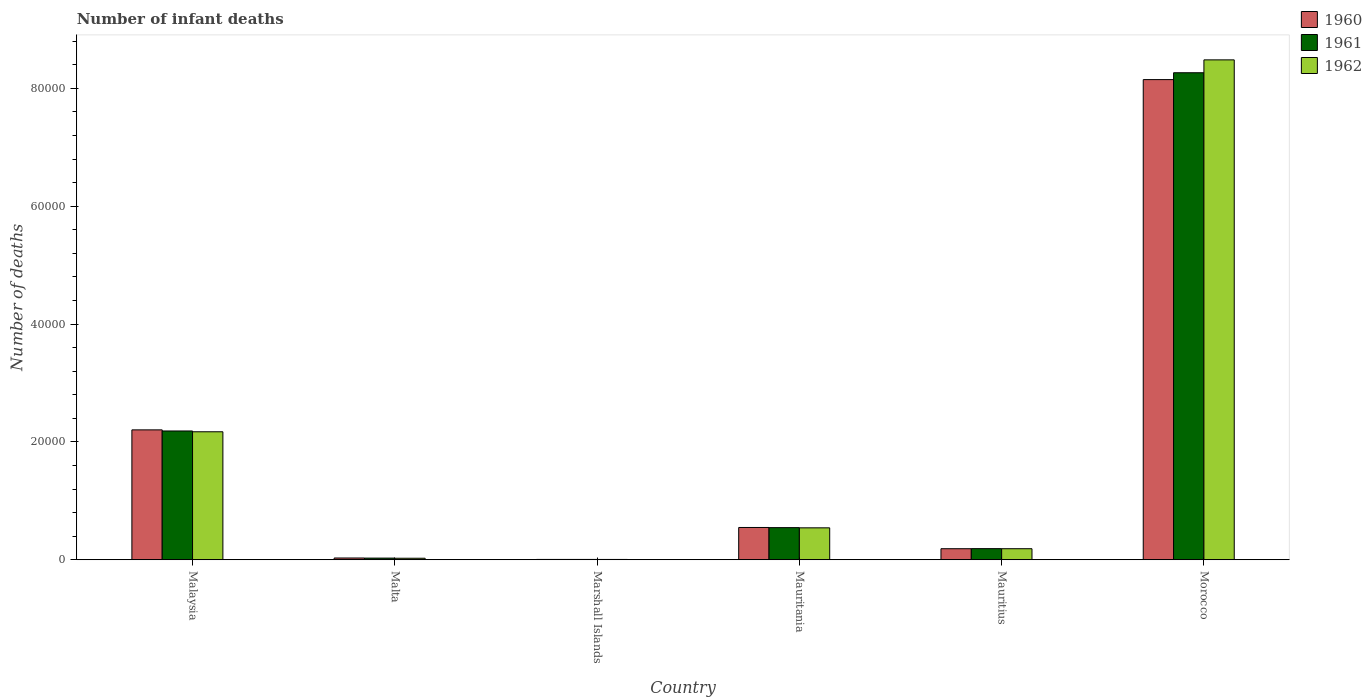How many groups of bars are there?
Your answer should be compact. 6. Are the number of bars per tick equal to the number of legend labels?
Your answer should be very brief. Yes. Are the number of bars on each tick of the X-axis equal?
Offer a terse response. Yes. How many bars are there on the 2nd tick from the left?
Provide a short and direct response. 3. What is the label of the 2nd group of bars from the left?
Your answer should be very brief. Malta. What is the number of infant deaths in 1962 in Mauritius?
Your response must be concise. 1876. Across all countries, what is the maximum number of infant deaths in 1962?
Your answer should be compact. 8.48e+04. In which country was the number of infant deaths in 1960 maximum?
Your answer should be compact. Morocco. In which country was the number of infant deaths in 1961 minimum?
Ensure brevity in your answer.  Marshall Islands. What is the total number of infant deaths in 1962 in the graph?
Your answer should be compact. 1.14e+05. What is the difference between the number of infant deaths in 1961 in Malta and that in Mauritania?
Make the answer very short. -5171. What is the difference between the number of infant deaths in 1961 in Mauritius and the number of infant deaths in 1962 in Malaysia?
Ensure brevity in your answer.  -1.98e+04. What is the average number of infant deaths in 1960 per country?
Provide a succinct answer. 1.85e+04. What is the difference between the number of infant deaths of/in 1962 and number of infant deaths of/in 1960 in Morocco?
Your response must be concise. 3350. In how many countries, is the number of infant deaths in 1962 greater than 52000?
Keep it short and to the point. 1. What is the ratio of the number of infant deaths in 1962 in Marshall Islands to that in Mauritania?
Your response must be concise. 0.01. What is the difference between the highest and the second highest number of infant deaths in 1962?
Make the answer very short. 1.63e+04. What is the difference between the highest and the lowest number of infant deaths in 1962?
Your answer should be compact. 8.48e+04. Is it the case that in every country, the sum of the number of infant deaths in 1962 and number of infant deaths in 1961 is greater than the number of infant deaths in 1960?
Offer a very short reply. Yes. Are all the bars in the graph horizontal?
Offer a very short reply. No. What is the difference between two consecutive major ticks on the Y-axis?
Ensure brevity in your answer.  2.00e+04. Does the graph contain grids?
Ensure brevity in your answer.  No. Where does the legend appear in the graph?
Ensure brevity in your answer.  Top right. How are the legend labels stacked?
Give a very brief answer. Vertical. What is the title of the graph?
Your answer should be compact. Number of infant deaths. What is the label or title of the X-axis?
Make the answer very short. Country. What is the label or title of the Y-axis?
Your response must be concise. Number of deaths. What is the Number of deaths of 1960 in Malaysia?
Provide a short and direct response. 2.20e+04. What is the Number of deaths of 1961 in Malaysia?
Offer a terse response. 2.19e+04. What is the Number of deaths of 1962 in Malaysia?
Make the answer very short. 2.17e+04. What is the Number of deaths in 1960 in Malta?
Your answer should be very brief. 301. What is the Number of deaths of 1961 in Malta?
Make the answer very short. 283. What is the Number of deaths in 1962 in Malta?
Provide a short and direct response. 258. What is the Number of deaths in 1960 in Mauritania?
Provide a succinct answer. 5480. What is the Number of deaths of 1961 in Mauritania?
Offer a very short reply. 5454. What is the Number of deaths of 1962 in Mauritania?
Make the answer very short. 5420. What is the Number of deaths of 1960 in Mauritius?
Offer a very short reply. 1875. What is the Number of deaths of 1961 in Mauritius?
Offer a terse response. 1890. What is the Number of deaths in 1962 in Mauritius?
Provide a short and direct response. 1876. What is the Number of deaths in 1960 in Morocco?
Provide a succinct answer. 8.15e+04. What is the Number of deaths of 1961 in Morocco?
Offer a terse response. 8.27e+04. What is the Number of deaths in 1962 in Morocco?
Offer a terse response. 8.48e+04. Across all countries, what is the maximum Number of deaths of 1960?
Offer a very short reply. 8.15e+04. Across all countries, what is the maximum Number of deaths in 1961?
Keep it short and to the point. 8.27e+04. Across all countries, what is the maximum Number of deaths in 1962?
Give a very brief answer. 8.48e+04. Across all countries, what is the minimum Number of deaths of 1961?
Make the answer very short. 56. What is the total Number of deaths in 1960 in the graph?
Keep it short and to the point. 1.11e+05. What is the total Number of deaths in 1961 in the graph?
Offer a terse response. 1.12e+05. What is the total Number of deaths in 1962 in the graph?
Your response must be concise. 1.14e+05. What is the difference between the Number of deaths of 1960 in Malaysia and that in Malta?
Offer a very short reply. 2.17e+04. What is the difference between the Number of deaths in 1961 in Malaysia and that in Malta?
Provide a succinct answer. 2.16e+04. What is the difference between the Number of deaths of 1962 in Malaysia and that in Malta?
Offer a terse response. 2.15e+04. What is the difference between the Number of deaths of 1960 in Malaysia and that in Marshall Islands?
Provide a short and direct response. 2.20e+04. What is the difference between the Number of deaths in 1961 in Malaysia and that in Marshall Islands?
Keep it short and to the point. 2.18e+04. What is the difference between the Number of deaths of 1962 in Malaysia and that in Marshall Islands?
Your response must be concise. 2.17e+04. What is the difference between the Number of deaths of 1960 in Malaysia and that in Mauritania?
Provide a short and direct response. 1.66e+04. What is the difference between the Number of deaths of 1961 in Malaysia and that in Mauritania?
Your answer should be compact. 1.64e+04. What is the difference between the Number of deaths of 1962 in Malaysia and that in Mauritania?
Give a very brief answer. 1.63e+04. What is the difference between the Number of deaths of 1960 in Malaysia and that in Mauritius?
Provide a short and direct response. 2.02e+04. What is the difference between the Number of deaths of 1961 in Malaysia and that in Mauritius?
Offer a very short reply. 2.00e+04. What is the difference between the Number of deaths of 1962 in Malaysia and that in Mauritius?
Offer a very short reply. 1.98e+04. What is the difference between the Number of deaths of 1960 in Malaysia and that in Morocco?
Offer a terse response. -5.94e+04. What is the difference between the Number of deaths in 1961 in Malaysia and that in Morocco?
Your answer should be compact. -6.08e+04. What is the difference between the Number of deaths of 1962 in Malaysia and that in Morocco?
Offer a terse response. -6.31e+04. What is the difference between the Number of deaths of 1960 in Malta and that in Marshall Islands?
Provide a succinct answer. 244. What is the difference between the Number of deaths of 1961 in Malta and that in Marshall Islands?
Provide a short and direct response. 227. What is the difference between the Number of deaths of 1962 in Malta and that in Marshall Islands?
Make the answer very short. 203. What is the difference between the Number of deaths in 1960 in Malta and that in Mauritania?
Provide a short and direct response. -5179. What is the difference between the Number of deaths in 1961 in Malta and that in Mauritania?
Offer a terse response. -5171. What is the difference between the Number of deaths in 1962 in Malta and that in Mauritania?
Your response must be concise. -5162. What is the difference between the Number of deaths in 1960 in Malta and that in Mauritius?
Keep it short and to the point. -1574. What is the difference between the Number of deaths in 1961 in Malta and that in Mauritius?
Provide a succinct answer. -1607. What is the difference between the Number of deaths of 1962 in Malta and that in Mauritius?
Offer a terse response. -1618. What is the difference between the Number of deaths of 1960 in Malta and that in Morocco?
Ensure brevity in your answer.  -8.12e+04. What is the difference between the Number of deaths of 1961 in Malta and that in Morocco?
Offer a very short reply. -8.24e+04. What is the difference between the Number of deaths in 1962 in Malta and that in Morocco?
Offer a very short reply. -8.46e+04. What is the difference between the Number of deaths of 1960 in Marshall Islands and that in Mauritania?
Your response must be concise. -5423. What is the difference between the Number of deaths of 1961 in Marshall Islands and that in Mauritania?
Ensure brevity in your answer.  -5398. What is the difference between the Number of deaths of 1962 in Marshall Islands and that in Mauritania?
Your answer should be compact. -5365. What is the difference between the Number of deaths in 1960 in Marshall Islands and that in Mauritius?
Offer a very short reply. -1818. What is the difference between the Number of deaths of 1961 in Marshall Islands and that in Mauritius?
Offer a terse response. -1834. What is the difference between the Number of deaths in 1962 in Marshall Islands and that in Mauritius?
Offer a very short reply. -1821. What is the difference between the Number of deaths of 1960 in Marshall Islands and that in Morocco?
Give a very brief answer. -8.14e+04. What is the difference between the Number of deaths in 1961 in Marshall Islands and that in Morocco?
Keep it short and to the point. -8.26e+04. What is the difference between the Number of deaths in 1962 in Marshall Islands and that in Morocco?
Provide a short and direct response. -8.48e+04. What is the difference between the Number of deaths in 1960 in Mauritania and that in Mauritius?
Your response must be concise. 3605. What is the difference between the Number of deaths in 1961 in Mauritania and that in Mauritius?
Ensure brevity in your answer.  3564. What is the difference between the Number of deaths of 1962 in Mauritania and that in Mauritius?
Give a very brief answer. 3544. What is the difference between the Number of deaths of 1960 in Mauritania and that in Morocco?
Give a very brief answer. -7.60e+04. What is the difference between the Number of deaths of 1961 in Mauritania and that in Morocco?
Your answer should be very brief. -7.72e+04. What is the difference between the Number of deaths in 1962 in Mauritania and that in Morocco?
Your response must be concise. -7.94e+04. What is the difference between the Number of deaths of 1960 in Mauritius and that in Morocco?
Provide a succinct answer. -7.96e+04. What is the difference between the Number of deaths of 1961 in Mauritius and that in Morocco?
Offer a terse response. -8.08e+04. What is the difference between the Number of deaths of 1962 in Mauritius and that in Morocco?
Provide a succinct answer. -8.30e+04. What is the difference between the Number of deaths of 1960 in Malaysia and the Number of deaths of 1961 in Malta?
Ensure brevity in your answer.  2.18e+04. What is the difference between the Number of deaths of 1960 in Malaysia and the Number of deaths of 1962 in Malta?
Your answer should be very brief. 2.18e+04. What is the difference between the Number of deaths in 1961 in Malaysia and the Number of deaths in 1962 in Malta?
Give a very brief answer. 2.16e+04. What is the difference between the Number of deaths in 1960 in Malaysia and the Number of deaths in 1961 in Marshall Islands?
Provide a succinct answer. 2.20e+04. What is the difference between the Number of deaths in 1960 in Malaysia and the Number of deaths in 1962 in Marshall Islands?
Your answer should be very brief. 2.20e+04. What is the difference between the Number of deaths of 1961 in Malaysia and the Number of deaths of 1962 in Marshall Islands?
Ensure brevity in your answer.  2.18e+04. What is the difference between the Number of deaths in 1960 in Malaysia and the Number of deaths in 1961 in Mauritania?
Make the answer very short. 1.66e+04. What is the difference between the Number of deaths in 1960 in Malaysia and the Number of deaths in 1962 in Mauritania?
Provide a succinct answer. 1.66e+04. What is the difference between the Number of deaths in 1961 in Malaysia and the Number of deaths in 1962 in Mauritania?
Make the answer very short. 1.64e+04. What is the difference between the Number of deaths of 1960 in Malaysia and the Number of deaths of 1961 in Mauritius?
Provide a short and direct response. 2.02e+04. What is the difference between the Number of deaths in 1960 in Malaysia and the Number of deaths in 1962 in Mauritius?
Keep it short and to the point. 2.02e+04. What is the difference between the Number of deaths in 1961 in Malaysia and the Number of deaths in 1962 in Mauritius?
Keep it short and to the point. 2.00e+04. What is the difference between the Number of deaths of 1960 in Malaysia and the Number of deaths of 1961 in Morocco?
Make the answer very short. -6.06e+04. What is the difference between the Number of deaths in 1960 in Malaysia and the Number of deaths in 1962 in Morocco?
Make the answer very short. -6.28e+04. What is the difference between the Number of deaths in 1961 in Malaysia and the Number of deaths in 1962 in Morocco?
Your answer should be very brief. -6.30e+04. What is the difference between the Number of deaths in 1960 in Malta and the Number of deaths in 1961 in Marshall Islands?
Your answer should be very brief. 245. What is the difference between the Number of deaths in 1960 in Malta and the Number of deaths in 1962 in Marshall Islands?
Give a very brief answer. 246. What is the difference between the Number of deaths of 1961 in Malta and the Number of deaths of 1962 in Marshall Islands?
Offer a very short reply. 228. What is the difference between the Number of deaths of 1960 in Malta and the Number of deaths of 1961 in Mauritania?
Provide a succinct answer. -5153. What is the difference between the Number of deaths in 1960 in Malta and the Number of deaths in 1962 in Mauritania?
Your answer should be compact. -5119. What is the difference between the Number of deaths of 1961 in Malta and the Number of deaths of 1962 in Mauritania?
Offer a very short reply. -5137. What is the difference between the Number of deaths of 1960 in Malta and the Number of deaths of 1961 in Mauritius?
Your answer should be compact. -1589. What is the difference between the Number of deaths in 1960 in Malta and the Number of deaths in 1962 in Mauritius?
Your answer should be very brief. -1575. What is the difference between the Number of deaths in 1961 in Malta and the Number of deaths in 1962 in Mauritius?
Make the answer very short. -1593. What is the difference between the Number of deaths of 1960 in Malta and the Number of deaths of 1961 in Morocco?
Offer a very short reply. -8.24e+04. What is the difference between the Number of deaths in 1960 in Malta and the Number of deaths in 1962 in Morocco?
Your answer should be compact. -8.45e+04. What is the difference between the Number of deaths of 1961 in Malta and the Number of deaths of 1962 in Morocco?
Provide a succinct answer. -8.46e+04. What is the difference between the Number of deaths of 1960 in Marshall Islands and the Number of deaths of 1961 in Mauritania?
Your answer should be compact. -5397. What is the difference between the Number of deaths in 1960 in Marshall Islands and the Number of deaths in 1962 in Mauritania?
Provide a short and direct response. -5363. What is the difference between the Number of deaths in 1961 in Marshall Islands and the Number of deaths in 1962 in Mauritania?
Provide a succinct answer. -5364. What is the difference between the Number of deaths in 1960 in Marshall Islands and the Number of deaths in 1961 in Mauritius?
Your answer should be compact. -1833. What is the difference between the Number of deaths in 1960 in Marshall Islands and the Number of deaths in 1962 in Mauritius?
Ensure brevity in your answer.  -1819. What is the difference between the Number of deaths of 1961 in Marshall Islands and the Number of deaths of 1962 in Mauritius?
Offer a terse response. -1820. What is the difference between the Number of deaths in 1960 in Marshall Islands and the Number of deaths in 1961 in Morocco?
Keep it short and to the point. -8.26e+04. What is the difference between the Number of deaths in 1960 in Marshall Islands and the Number of deaths in 1962 in Morocco?
Your answer should be compact. -8.48e+04. What is the difference between the Number of deaths in 1961 in Marshall Islands and the Number of deaths in 1962 in Morocco?
Provide a succinct answer. -8.48e+04. What is the difference between the Number of deaths of 1960 in Mauritania and the Number of deaths of 1961 in Mauritius?
Ensure brevity in your answer.  3590. What is the difference between the Number of deaths in 1960 in Mauritania and the Number of deaths in 1962 in Mauritius?
Provide a succinct answer. 3604. What is the difference between the Number of deaths of 1961 in Mauritania and the Number of deaths of 1962 in Mauritius?
Your answer should be compact. 3578. What is the difference between the Number of deaths in 1960 in Mauritania and the Number of deaths in 1961 in Morocco?
Your answer should be compact. -7.72e+04. What is the difference between the Number of deaths in 1960 in Mauritania and the Number of deaths in 1962 in Morocco?
Your response must be concise. -7.94e+04. What is the difference between the Number of deaths of 1961 in Mauritania and the Number of deaths of 1962 in Morocco?
Keep it short and to the point. -7.94e+04. What is the difference between the Number of deaths of 1960 in Mauritius and the Number of deaths of 1961 in Morocco?
Keep it short and to the point. -8.08e+04. What is the difference between the Number of deaths of 1960 in Mauritius and the Number of deaths of 1962 in Morocco?
Your response must be concise. -8.30e+04. What is the difference between the Number of deaths of 1961 in Mauritius and the Number of deaths of 1962 in Morocco?
Your response must be concise. -8.30e+04. What is the average Number of deaths in 1960 per country?
Provide a short and direct response. 1.85e+04. What is the average Number of deaths of 1961 per country?
Give a very brief answer. 1.87e+04. What is the average Number of deaths of 1962 per country?
Offer a very short reply. 1.90e+04. What is the difference between the Number of deaths of 1960 and Number of deaths of 1961 in Malaysia?
Keep it short and to the point. 186. What is the difference between the Number of deaths in 1960 and Number of deaths in 1962 in Malaysia?
Your response must be concise. 323. What is the difference between the Number of deaths of 1961 and Number of deaths of 1962 in Malaysia?
Your response must be concise. 137. What is the difference between the Number of deaths of 1960 and Number of deaths of 1961 in Malta?
Provide a short and direct response. 18. What is the difference between the Number of deaths of 1961 and Number of deaths of 1962 in Malta?
Ensure brevity in your answer.  25. What is the difference between the Number of deaths in 1960 and Number of deaths in 1961 in Marshall Islands?
Keep it short and to the point. 1. What is the difference between the Number of deaths of 1961 and Number of deaths of 1962 in Marshall Islands?
Offer a terse response. 1. What is the difference between the Number of deaths of 1960 and Number of deaths of 1961 in Mauritania?
Keep it short and to the point. 26. What is the difference between the Number of deaths of 1960 and Number of deaths of 1962 in Mauritania?
Your answer should be compact. 60. What is the difference between the Number of deaths in 1961 and Number of deaths in 1962 in Mauritania?
Provide a succinct answer. 34. What is the difference between the Number of deaths of 1960 and Number of deaths of 1961 in Mauritius?
Offer a very short reply. -15. What is the difference between the Number of deaths of 1960 and Number of deaths of 1961 in Morocco?
Ensure brevity in your answer.  -1166. What is the difference between the Number of deaths in 1960 and Number of deaths in 1962 in Morocco?
Give a very brief answer. -3350. What is the difference between the Number of deaths of 1961 and Number of deaths of 1962 in Morocco?
Offer a very short reply. -2184. What is the ratio of the Number of deaths of 1960 in Malaysia to that in Malta?
Your answer should be compact. 73.24. What is the ratio of the Number of deaths in 1961 in Malaysia to that in Malta?
Your answer should be very brief. 77.24. What is the ratio of the Number of deaths of 1962 in Malaysia to that in Malta?
Provide a succinct answer. 84.2. What is the ratio of the Number of deaths in 1960 in Malaysia to that in Marshall Islands?
Offer a very short reply. 386.77. What is the ratio of the Number of deaths in 1961 in Malaysia to that in Marshall Islands?
Give a very brief answer. 390.36. What is the ratio of the Number of deaths in 1962 in Malaysia to that in Marshall Islands?
Your answer should be very brief. 394.96. What is the ratio of the Number of deaths of 1960 in Malaysia to that in Mauritania?
Offer a terse response. 4.02. What is the ratio of the Number of deaths in 1961 in Malaysia to that in Mauritania?
Provide a short and direct response. 4.01. What is the ratio of the Number of deaths in 1962 in Malaysia to that in Mauritania?
Offer a terse response. 4.01. What is the ratio of the Number of deaths of 1960 in Malaysia to that in Mauritius?
Your response must be concise. 11.76. What is the ratio of the Number of deaths in 1961 in Malaysia to that in Mauritius?
Keep it short and to the point. 11.57. What is the ratio of the Number of deaths in 1962 in Malaysia to that in Mauritius?
Offer a very short reply. 11.58. What is the ratio of the Number of deaths in 1960 in Malaysia to that in Morocco?
Keep it short and to the point. 0.27. What is the ratio of the Number of deaths in 1961 in Malaysia to that in Morocco?
Offer a very short reply. 0.26. What is the ratio of the Number of deaths of 1962 in Malaysia to that in Morocco?
Provide a short and direct response. 0.26. What is the ratio of the Number of deaths of 1960 in Malta to that in Marshall Islands?
Your answer should be very brief. 5.28. What is the ratio of the Number of deaths of 1961 in Malta to that in Marshall Islands?
Offer a terse response. 5.05. What is the ratio of the Number of deaths in 1962 in Malta to that in Marshall Islands?
Ensure brevity in your answer.  4.69. What is the ratio of the Number of deaths in 1960 in Malta to that in Mauritania?
Your answer should be very brief. 0.05. What is the ratio of the Number of deaths in 1961 in Malta to that in Mauritania?
Your answer should be very brief. 0.05. What is the ratio of the Number of deaths in 1962 in Malta to that in Mauritania?
Provide a succinct answer. 0.05. What is the ratio of the Number of deaths of 1960 in Malta to that in Mauritius?
Offer a terse response. 0.16. What is the ratio of the Number of deaths in 1961 in Malta to that in Mauritius?
Offer a terse response. 0.15. What is the ratio of the Number of deaths of 1962 in Malta to that in Mauritius?
Your answer should be compact. 0.14. What is the ratio of the Number of deaths in 1960 in Malta to that in Morocco?
Offer a terse response. 0. What is the ratio of the Number of deaths of 1961 in Malta to that in Morocco?
Provide a short and direct response. 0. What is the ratio of the Number of deaths in 1962 in Malta to that in Morocco?
Provide a short and direct response. 0. What is the ratio of the Number of deaths in 1960 in Marshall Islands to that in Mauritania?
Provide a succinct answer. 0.01. What is the ratio of the Number of deaths in 1961 in Marshall Islands to that in Mauritania?
Make the answer very short. 0.01. What is the ratio of the Number of deaths of 1962 in Marshall Islands to that in Mauritania?
Your answer should be very brief. 0.01. What is the ratio of the Number of deaths of 1960 in Marshall Islands to that in Mauritius?
Your response must be concise. 0.03. What is the ratio of the Number of deaths of 1961 in Marshall Islands to that in Mauritius?
Keep it short and to the point. 0.03. What is the ratio of the Number of deaths of 1962 in Marshall Islands to that in Mauritius?
Your response must be concise. 0.03. What is the ratio of the Number of deaths in 1960 in Marshall Islands to that in Morocco?
Make the answer very short. 0. What is the ratio of the Number of deaths of 1961 in Marshall Islands to that in Morocco?
Keep it short and to the point. 0. What is the ratio of the Number of deaths in 1962 in Marshall Islands to that in Morocco?
Offer a terse response. 0. What is the ratio of the Number of deaths in 1960 in Mauritania to that in Mauritius?
Offer a very short reply. 2.92. What is the ratio of the Number of deaths in 1961 in Mauritania to that in Mauritius?
Offer a very short reply. 2.89. What is the ratio of the Number of deaths in 1962 in Mauritania to that in Mauritius?
Provide a short and direct response. 2.89. What is the ratio of the Number of deaths in 1960 in Mauritania to that in Morocco?
Your answer should be very brief. 0.07. What is the ratio of the Number of deaths of 1961 in Mauritania to that in Morocco?
Ensure brevity in your answer.  0.07. What is the ratio of the Number of deaths in 1962 in Mauritania to that in Morocco?
Keep it short and to the point. 0.06. What is the ratio of the Number of deaths in 1960 in Mauritius to that in Morocco?
Ensure brevity in your answer.  0.02. What is the ratio of the Number of deaths in 1961 in Mauritius to that in Morocco?
Keep it short and to the point. 0.02. What is the ratio of the Number of deaths in 1962 in Mauritius to that in Morocco?
Offer a terse response. 0.02. What is the difference between the highest and the second highest Number of deaths of 1960?
Offer a very short reply. 5.94e+04. What is the difference between the highest and the second highest Number of deaths in 1961?
Give a very brief answer. 6.08e+04. What is the difference between the highest and the second highest Number of deaths of 1962?
Give a very brief answer. 6.31e+04. What is the difference between the highest and the lowest Number of deaths of 1960?
Offer a terse response. 8.14e+04. What is the difference between the highest and the lowest Number of deaths in 1961?
Ensure brevity in your answer.  8.26e+04. What is the difference between the highest and the lowest Number of deaths in 1962?
Your answer should be very brief. 8.48e+04. 